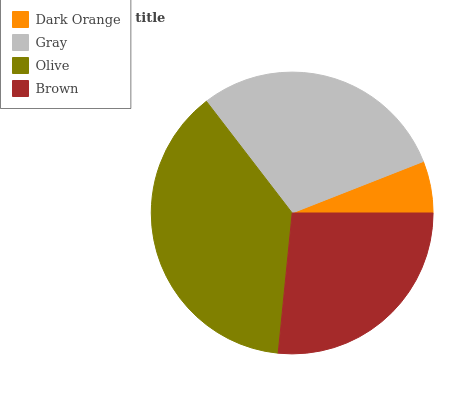Is Dark Orange the minimum?
Answer yes or no. Yes. Is Olive the maximum?
Answer yes or no. Yes. Is Gray the minimum?
Answer yes or no. No. Is Gray the maximum?
Answer yes or no. No. Is Gray greater than Dark Orange?
Answer yes or no. Yes. Is Dark Orange less than Gray?
Answer yes or no. Yes. Is Dark Orange greater than Gray?
Answer yes or no. No. Is Gray less than Dark Orange?
Answer yes or no. No. Is Gray the high median?
Answer yes or no. Yes. Is Brown the low median?
Answer yes or no. Yes. Is Brown the high median?
Answer yes or no. No. Is Gray the low median?
Answer yes or no. No. 